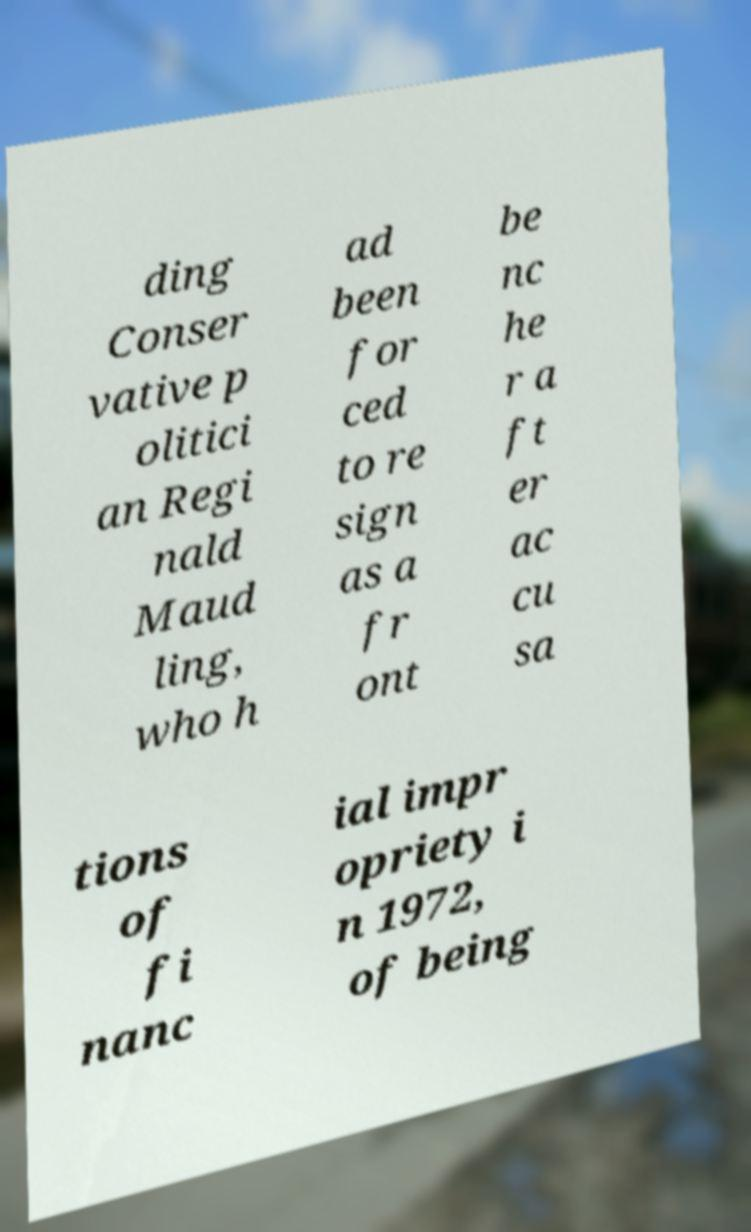Please read and relay the text visible in this image. What does it say? ding Conser vative p olitici an Regi nald Maud ling, who h ad been for ced to re sign as a fr ont be nc he r a ft er ac cu sa tions of fi nanc ial impr opriety i n 1972, of being 